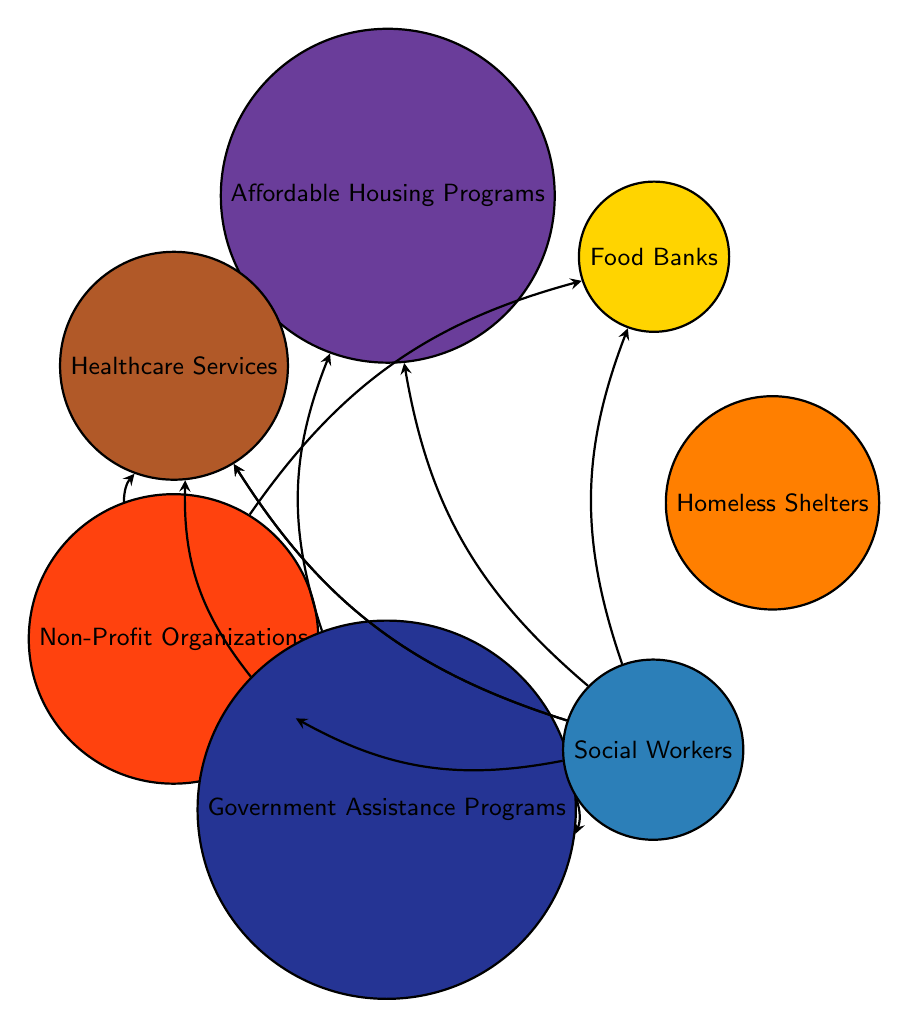What are the nodes representing social services in the diagram? The diagram consists of the following nodes representing social services: Homeless Shelters, Food Banks, Affordable Housing Programs, Healthcare Services, Non-Profit Organizations, Government Assistance Programs, and Social Workers.
Answer: Homeless Shelters, Food Banks, Affordable Housing Programs, Healthcare Services, Non-Profit Organizations, Government Assistance Programs, Social Workers How many connections are there in total? By counting the connections listed in the data, there are 10 unique connections between nodes, indicating the support interactions among different services.
Answer: 10 Which service connects directly to Non-Profit Organizations? Looking at the connections from the Non-Profit Organizations node, there are direct links to Food Banks and Healthcare Services, showing the services they connect to.
Answer: Food Banks, Healthcare Services What is the role of Social Workers in this diagram? Social Workers have multiple connections leading to various social services, which indicates their central role in facilitating access and connections to the services available for low-income families.
Answer: Facilitate access Which service is linked to both Government Assistance Programs and Affordable Housing Programs? The connection from Government Assistance Programs to Affordable Housing Programs indicates that both services are directly linked, allowing families to access affordable housing through government aid.
Answer: Affordable Housing Programs How many nodes are connected to Social Workers? By reviewing the connections from Social Workers in the diagram, they connect to six nodes: Homeless Shelters, Food Banks, Affordable Housing Programs, Healthcare Services, Non-Profit Organizations, and Government Assistance Programs.
Answer: 6 What is the relationship between Non-Profit Organizations and Food Banks? The connection from Non-Profit Organizations to Food Banks indicates that Non-Profit Organizations support or provide access to Food Banks, facilitating food assistance to families in need.
Answer: Support Which node has the most connections? Analyzing the relationships in the diagram, Social Workers have the highest number of direct connections to other services, as they link to six different nodes, making them the most connected node.
Answer: Social Workers 